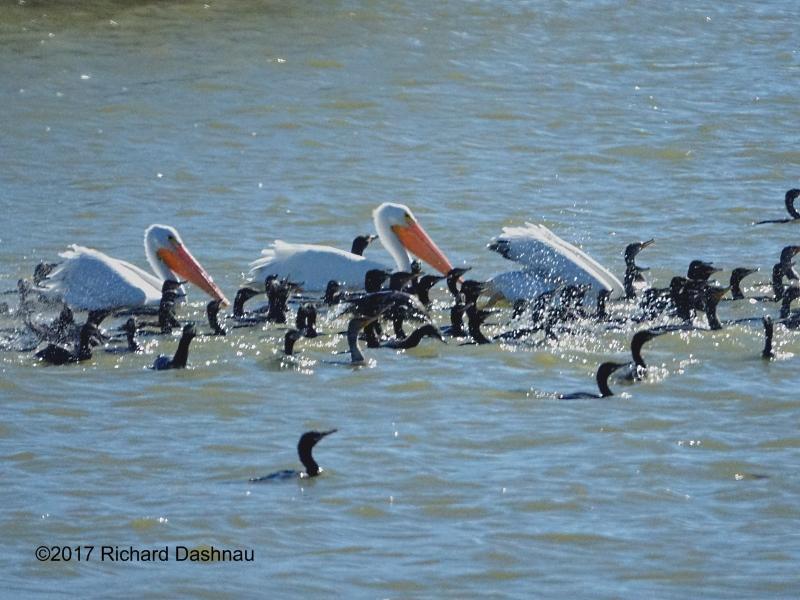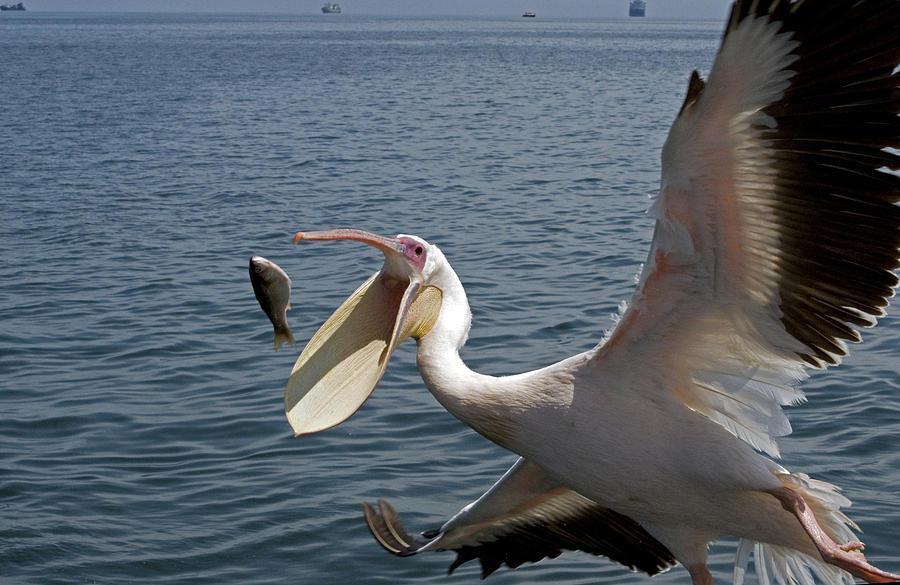The first image is the image on the left, the second image is the image on the right. Analyze the images presented: Is the assertion "One of the pelicans is opening its mouth wide." valid? Answer yes or no. Yes. The first image is the image on the left, the second image is the image on the right. Examine the images to the left and right. Is the description "An image shows exactly one pelican, which has a gaping mouth." accurate? Answer yes or no. Yes. 